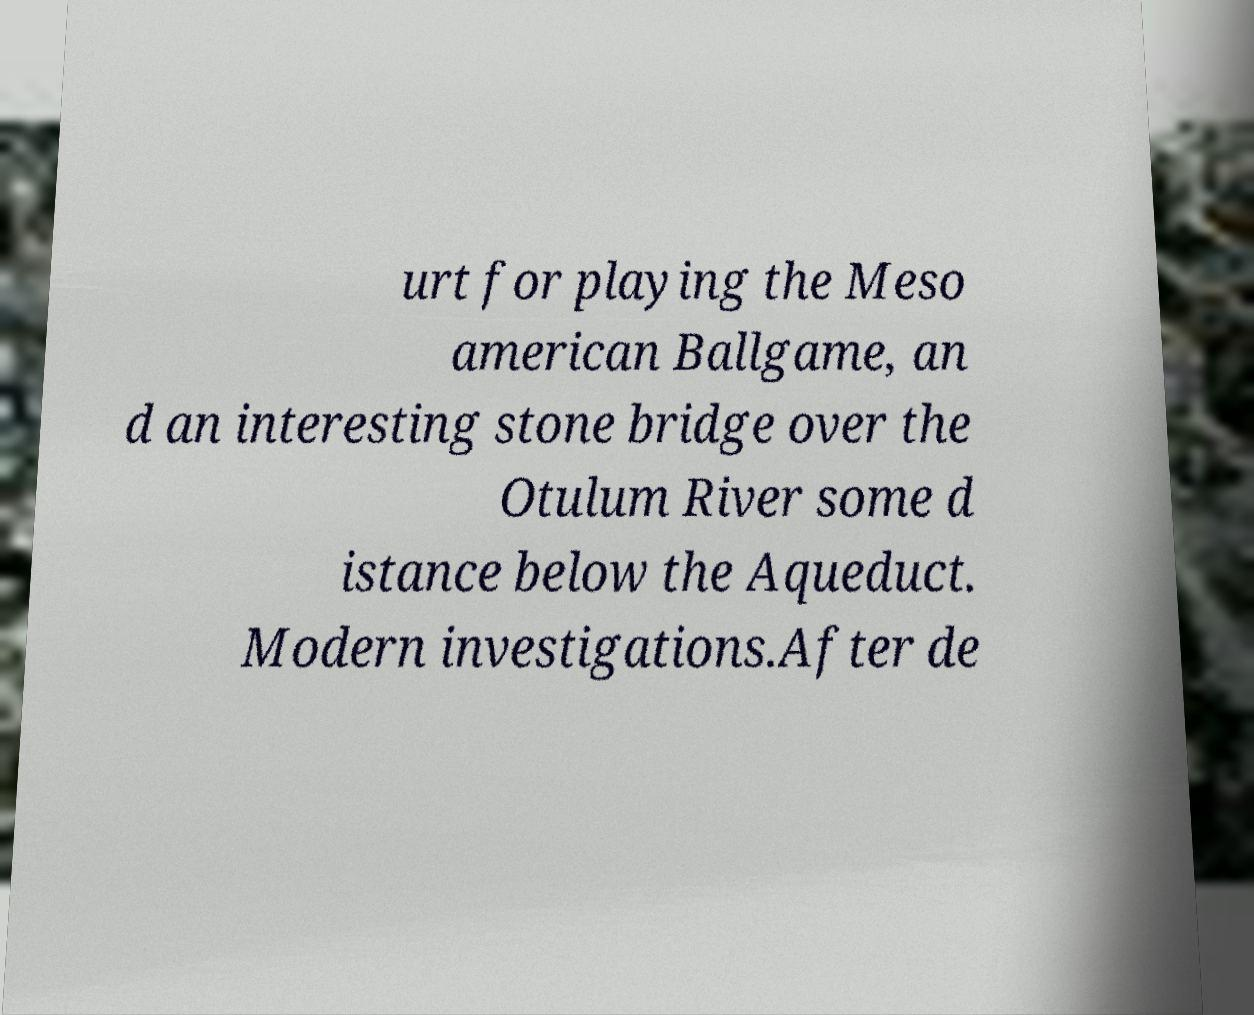Can you accurately transcribe the text from the provided image for me? urt for playing the Meso american Ballgame, an d an interesting stone bridge over the Otulum River some d istance below the Aqueduct. Modern investigations.After de 